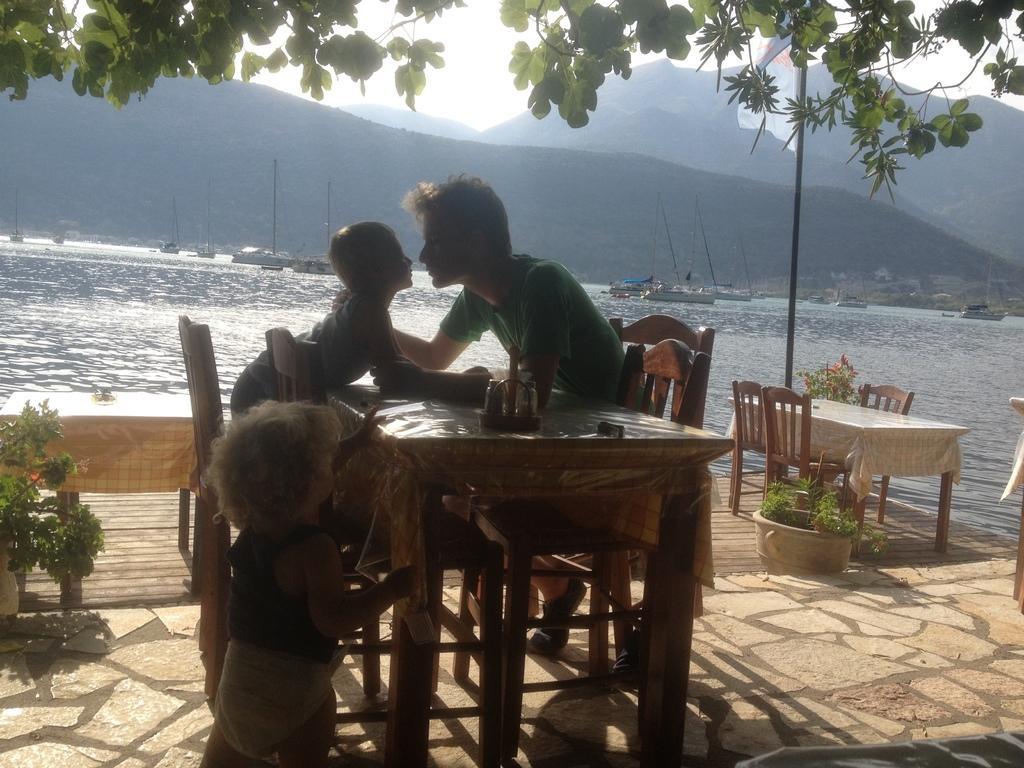Could you give a brief overview of what you see in this image? In this image I can see a two childrens and the man is sitting on the chair. On the table there is a holder. At the background we can see mountains,ship and a water. There are flower pots. 